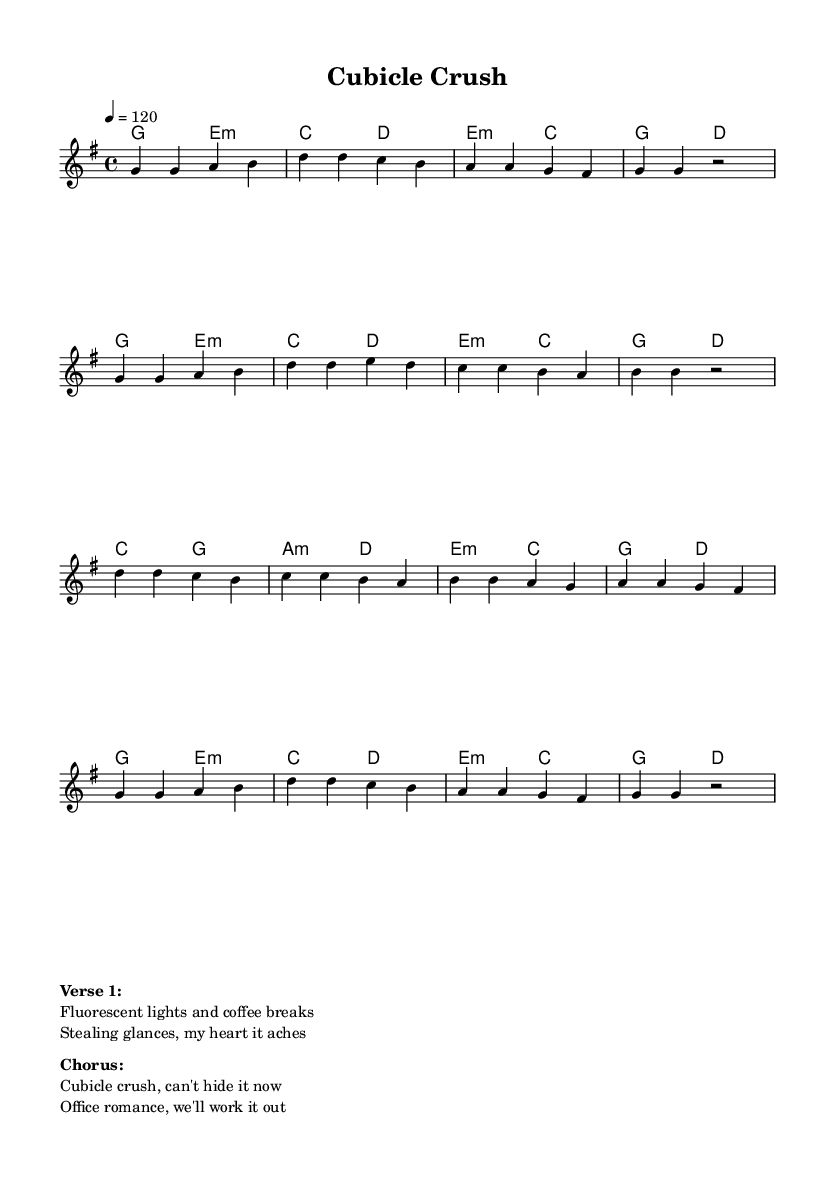What is the key signature of this music? The key signature indicated in the global section specifies that it is in G major, which has one sharp.
Answer: G major What is the time signature of this music? The time signature is indicated at the beginning of the score as 4/4, which means there are four beats in each measure.
Answer: 4/4 What is the tempo marking for this song? The tempo is indicated as 4 = 120, which denotes that there are 120 beats per minute, marking the speed of the song.
Answer: 120 How many measures are there in the melody section? By counting the groups of notes separated by the vertical lines, the melody section consists of 16 measures in total.
Answer: 16 Which chord appears most frequently in the harmonies? The harmony section has the G major chord, which is repeated multiple times, making it the most frequently appearing chord in this piece.
Answer: G What is the main theme expressed in the lyrics of the chorus? The lyrics of the chorus speak about an office romance and a hidden crush, clearly summarizing the relationship dynamics in a workplace setting.
Answer: Office romance How does the tempo affect the overall feel of the song? The tempo of 120 beats per minute contributes to an upbeat and lively feel, fitting the pop genre and enhancing the positive theme of workplace relationships.
Answer: Upbeat 